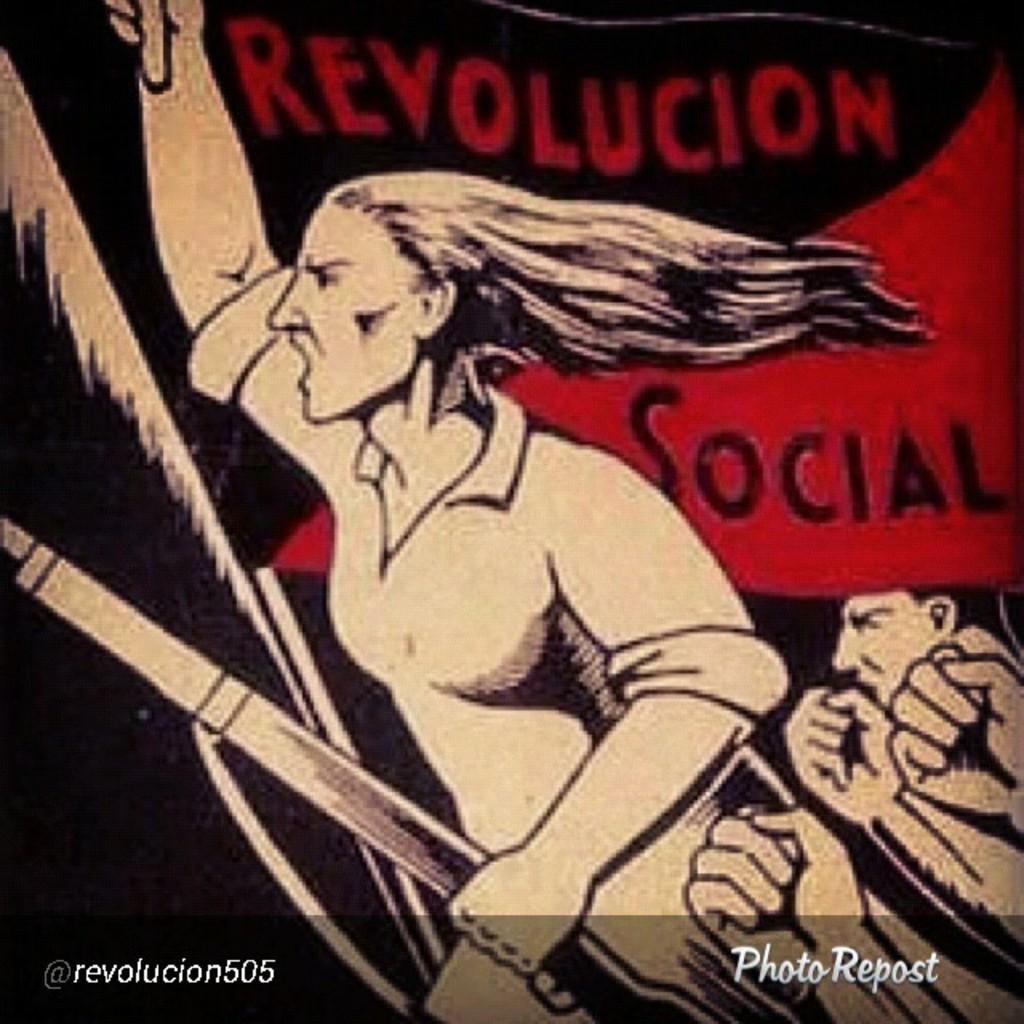Which user took this photo?
Make the answer very short. Revolucion505. 